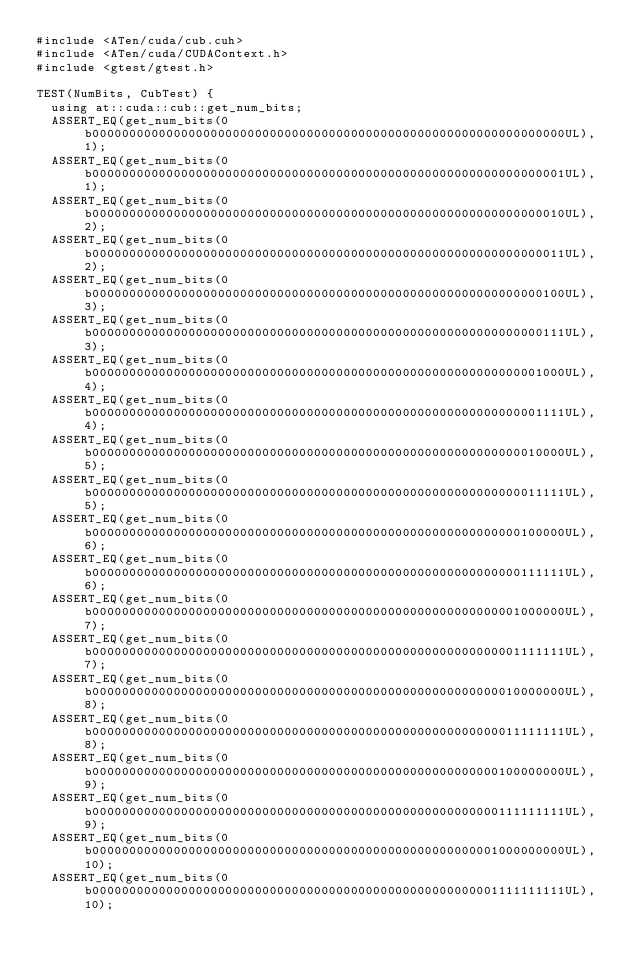<code> <loc_0><loc_0><loc_500><loc_500><_Cuda_>#include <ATen/cuda/cub.cuh>
#include <ATen/cuda/CUDAContext.h>
#include <gtest/gtest.h>

TEST(NumBits, CubTest) {
  using at::cuda::cub::get_num_bits;
  ASSERT_EQ(get_num_bits(0b0000000000000000000000000000000000000000000000000000000000000000UL), 1);
  ASSERT_EQ(get_num_bits(0b0000000000000000000000000000000000000000000000000000000000000001UL), 1);
  ASSERT_EQ(get_num_bits(0b0000000000000000000000000000000000000000000000000000000000000010UL), 2);
  ASSERT_EQ(get_num_bits(0b0000000000000000000000000000000000000000000000000000000000000011UL), 2);
  ASSERT_EQ(get_num_bits(0b0000000000000000000000000000000000000000000000000000000000000100UL), 3);
  ASSERT_EQ(get_num_bits(0b0000000000000000000000000000000000000000000000000000000000000111UL), 3);
  ASSERT_EQ(get_num_bits(0b0000000000000000000000000000000000000000000000000000000000001000UL), 4);
  ASSERT_EQ(get_num_bits(0b0000000000000000000000000000000000000000000000000000000000001111UL), 4);
  ASSERT_EQ(get_num_bits(0b0000000000000000000000000000000000000000000000000000000000010000UL), 5);
  ASSERT_EQ(get_num_bits(0b0000000000000000000000000000000000000000000000000000000000011111UL), 5);
  ASSERT_EQ(get_num_bits(0b0000000000000000000000000000000000000000000000000000000000100000UL), 6);
  ASSERT_EQ(get_num_bits(0b0000000000000000000000000000000000000000000000000000000000111111UL), 6);
  ASSERT_EQ(get_num_bits(0b0000000000000000000000000000000000000000000000000000000001000000UL), 7);
  ASSERT_EQ(get_num_bits(0b0000000000000000000000000000000000000000000000000000000001111111UL), 7);
  ASSERT_EQ(get_num_bits(0b0000000000000000000000000000000000000000000000000000000010000000UL), 8);
  ASSERT_EQ(get_num_bits(0b0000000000000000000000000000000000000000000000000000000011111111UL), 8);
  ASSERT_EQ(get_num_bits(0b0000000000000000000000000000000000000000000000000000000100000000UL), 9);
  ASSERT_EQ(get_num_bits(0b0000000000000000000000000000000000000000000000000000000111111111UL), 9);
  ASSERT_EQ(get_num_bits(0b0000000000000000000000000000000000000000000000000000001000000000UL), 10);
  ASSERT_EQ(get_num_bits(0b0000000000000000000000000000000000000000000000000000001111111111UL), 10);</code> 